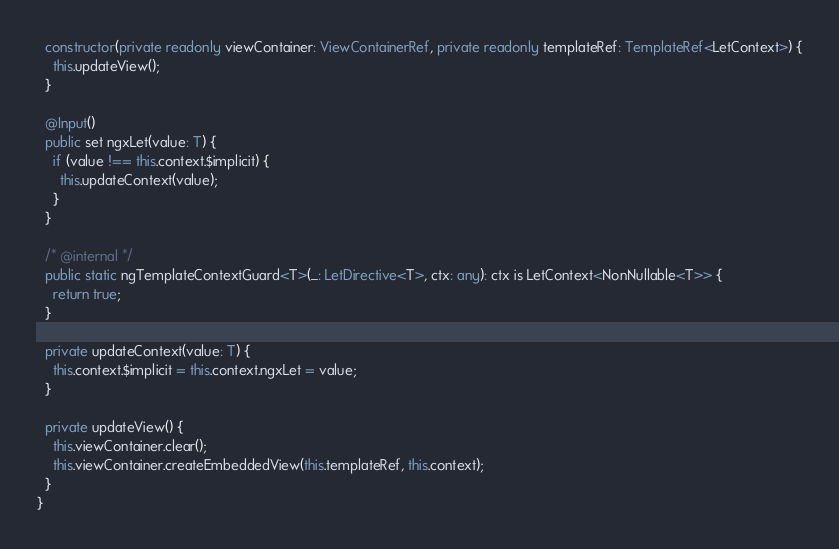Convert code to text. <code><loc_0><loc_0><loc_500><loc_500><_TypeScript_>
  constructor(private readonly viewContainer: ViewContainerRef, private readonly templateRef: TemplateRef<LetContext>) {
    this.updateView();
  }

  @Input()
  public set ngxLet(value: T) {
    if (value !== this.context.$implicit) {
      this.updateContext(value);
    }
  }

  /* @internal */
  public static ngTemplateContextGuard<T>(_: LetDirective<T>, ctx: any): ctx is LetContext<NonNullable<T>> {
    return true;
  }

  private updateContext(value: T) {
    this.context.$implicit = this.context.ngxLet = value;
  }

  private updateView() {
    this.viewContainer.clear();
    this.viewContainer.createEmbeddedView(this.templateRef, this.context);
  }
}
</code> 